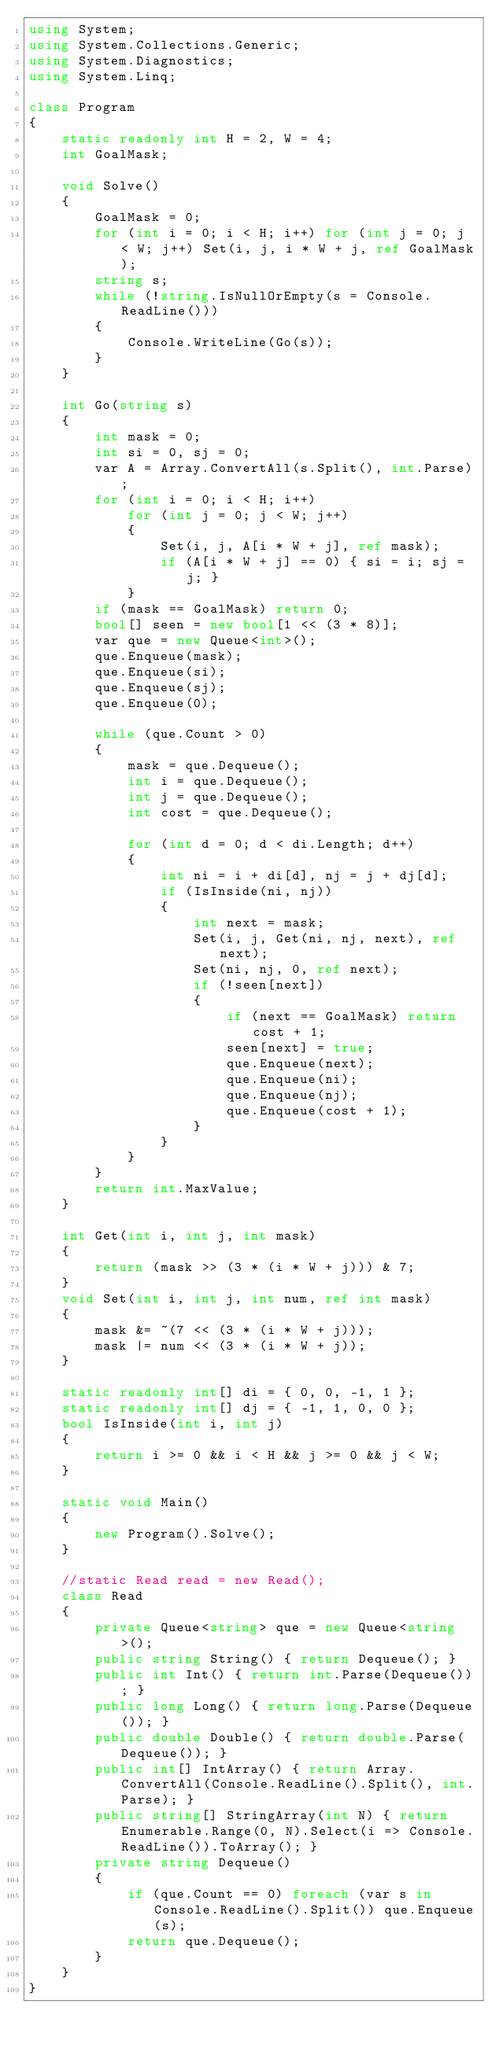<code> <loc_0><loc_0><loc_500><loc_500><_C#_>using System;
using System.Collections.Generic;
using System.Diagnostics;
using System.Linq;

class Program
{
    static readonly int H = 2, W = 4;
    int GoalMask;

    void Solve()
    {
        GoalMask = 0;
        for (int i = 0; i < H; i++) for (int j = 0; j < W; j++) Set(i, j, i * W + j, ref GoalMask);
        string s;
        while (!string.IsNullOrEmpty(s = Console.ReadLine()))
        {
            Console.WriteLine(Go(s));
        }
    }

    int Go(string s)
    {
        int mask = 0;
        int si = 0, sj = 0;
        var A = Array.ConvertAll(s.Split(), int.Parse);
        for (int i = 0; i < H; i++)
            for (int j = 0; j < W; j++)
            {
                Set(i, j, A[i * W + j], ref mask);
                if (A[i * W + j] == 0) { si = i; sj = j; }
            }
        if (mask == GoalMask) return 0;
        bool[] seen = new bool[1 << (3 * 8)];
        var que = new Queue<int>();
        que.Enqueue(mask);
        que.Enqueue(si);
        que.Enqueue(sj);
        que.Enqueue(0);

        while (que.Count > 0)
        {
            mask = que.Dequeue();
            int i = que.Dequeue();
            int j = que.Dequeue();
            int cost = que.Dequeue();

            for (int d = 0; d < di.Length; d++)
            {
                int ni = i + di[d], nj = j + dj[d];
                if (IsInside(ni, nj))
                {
                    int next = mask;
                    Set(i, j, Get(ni, nj, next), ref next);
                    Set(ni, nj, 0, ref next);
                    if (!seen[next])
                    {
                        if (next == GoalMask) return cost + 1;
                        seen[next] = true;
                        que.Enqueue(next);
                        que.Enqueue(ni);
                        que.Enqueue(nj);
                        que.Enqueue(cost + 1);
                    }
                }
            }
        }
        return int.MaxValue;
    }

    int Get(int i, int j, int mask)
    {
        return (mask >> (3 * (i * W + j))) & 7;
    }
    void Set(int i, int j, int num, ref int mask)
    {
        mask &= ~(7 << (3 * (i * W + j)));
        mask |= num << (3 * (i * W + j));
    }

    static readonly int[] di = { 0, 0, -1, 1 };
    static readonly int[] dj = { -1, 1, 0, 0 };
    bool IsInside(int i, int j)
    {
        return i >= 0 && i < H && j >= 0 && j < W;
    }

    static void Main()
    {
        new Program().Solve(); 
    }

    //static Read read = new Read();
    class Read
    {
        private Queue<string> que = new Queue<string>();
        public string String() { return Dequeue(); }
        public int Int() { return int.Parse(Dequeue()); }
        public long Long() { return long.Parse(Dequeue()); }
        public double Double() { return double.Parse(Dequeue()); }
        public int[] IntArray() { return Array.ConvertAll(Console.ReadLine().Split(), int.Parse); }
        public string[] StringArray(int N) { return Enumerable.Range(0, N).Select(i => Console.ReadLine()).ToArray(); }
        private string Dequeue()
        {
            if (que.Count == 0) foreach (var s in Console.ReadLine().Split()) que.Enqueue(s);
            return que.Dequeue();
        }
    }
}</code> 